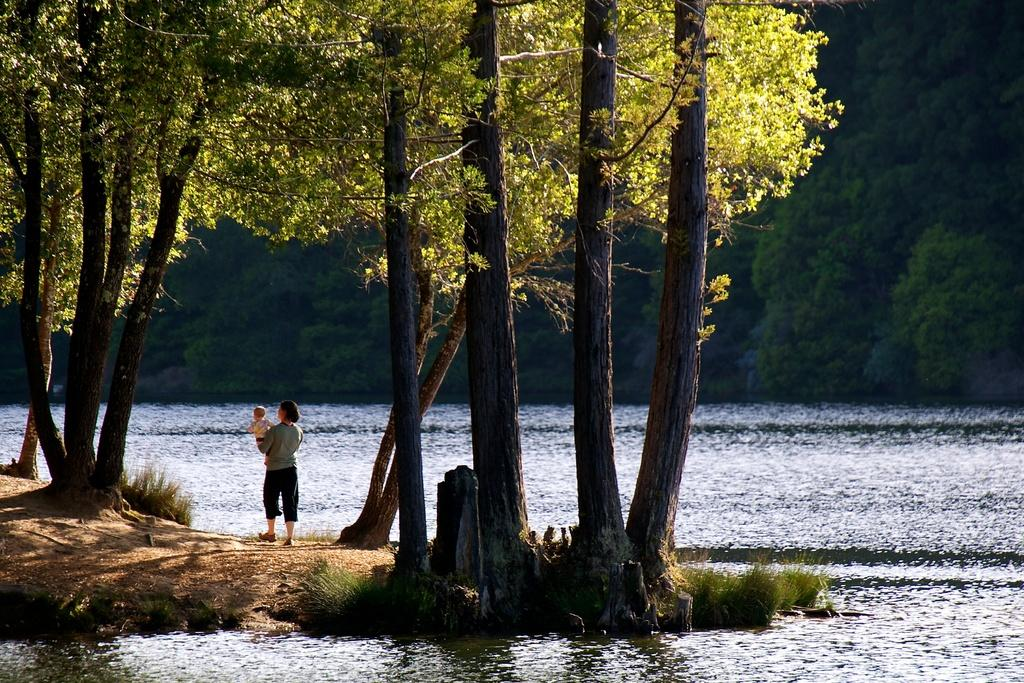What is the person in the image doing? The person in the image is carrying a baby. What natural feature can be seen in the image? There is a river in the image. What type of vegetation is present in the image? There are trees with branches and leaves in the image. What type of ground cover is visible in the image? There is grass in the image. How many bones can be seen in the image? There are no bones visible in the image. What type of lizards can be seen in the image? There are no lizards present in the image. 